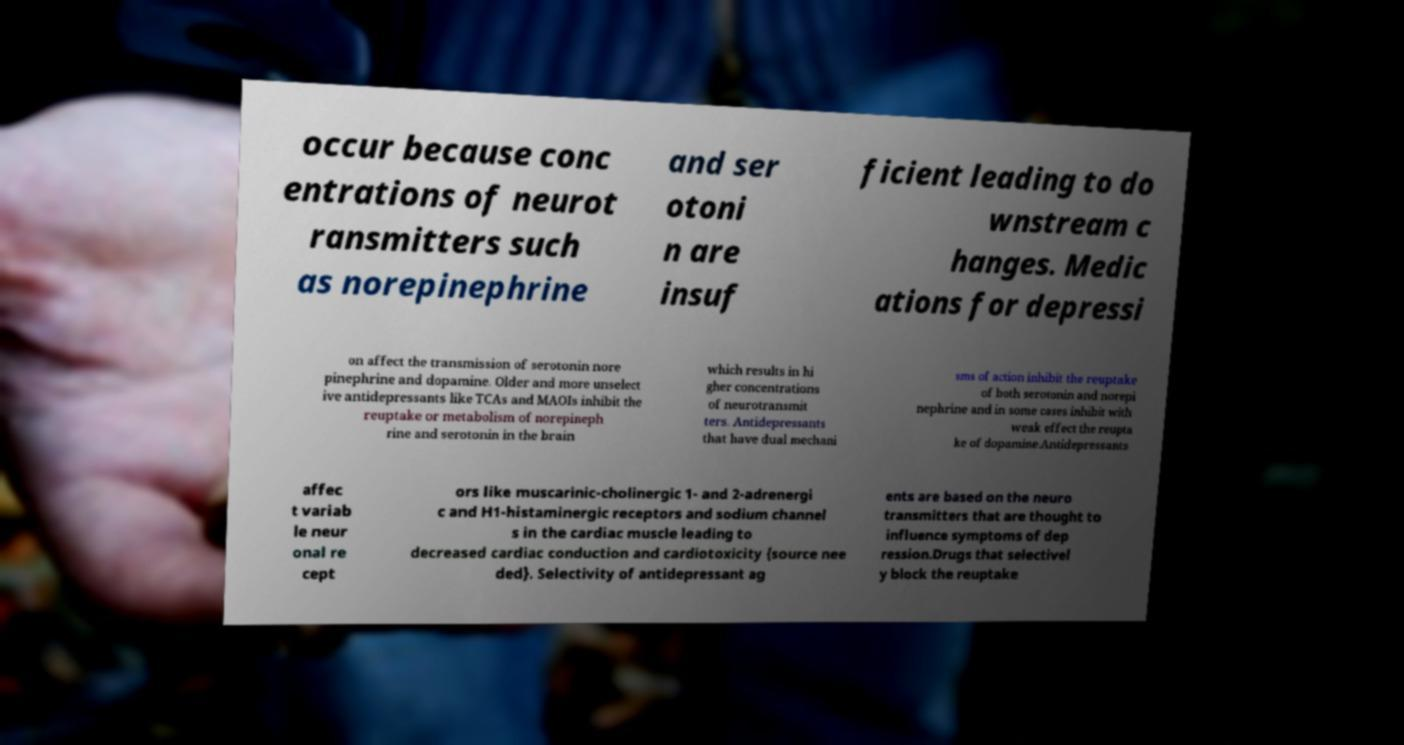I need the written content from this picture converted into text. Can you do that? occur because conc entrations of neurot ransmitters such as norepinephrine and ser otoni n are insuf ficient leading to do wnstream c hanges. Medic ations for depressi on affect the transmission of serotonin nore pinephrine and dopamine. Older and more unselect ive antidepressants like TCAs and MAOIs inhibit the reuptake or metabolism of norepineph rine and serotonin in the brain which results in hi gher concentrations of neurotransmit ters. Antidepressants that have dual mechani sms of action inhibit the reuptake of both serotonin and norepi nephrine and in some cases inhibit with weak effect the reupta ke of dopamine.Antidepressants affec t variab le neur onal re cept ors like muscarinic-cholinergic 1- and 2-adrenergi c and H1-histaminergic receptors and sodium channel s in the cardiac muscle leading to decreased cardiac conduction and cardiotoxicity {source nee ded}. Selectivity of antidepressant ag ents are based on the neuro transmitters that are thought to influence symptoms of dep ression.Drugs that selectivel y block the reuptake 